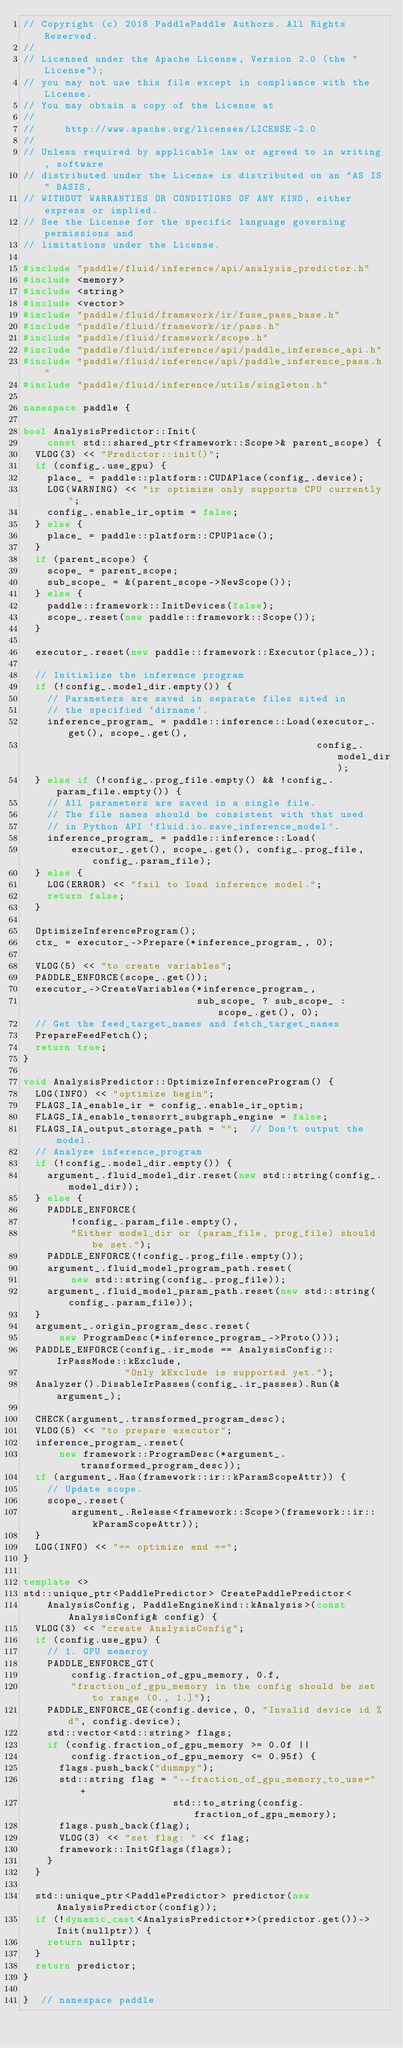<code> <loc_0><loc_0><loc_500><loc_500><_C++_>// Copyright (c) 2018 PaddlePaddle Authors. All Rights Reserved.
//
// Licensed under the Apache License, Version 2.0 (the "License");
// you may not use this file except in compliance with the License.
// You may obtain a copy of the License at
//
//     http://www.apache.org/licenses/LICENSE-2.0
//
// Unless required by applicable law or agreed to in writing, software
// distributed under the License is distributed on an "AS IS" BASIS,
// WITHOUT WARRANTIES OR CONDITIONS OF ANY KIND, either express or implied.
// See the License for the specific language governing permissions and
// limitations under the License.

#include "paddle/fluid/inference/api/analysis_predictor.h"
#include <memory>
#include <string>
#include <vector>
#include "paddle/fluid/framework/ir/fuse_pass_base.h"
#include "paddle/fluid/framework/ir/pass.h"
#include "paddle/fluid/framework/scope.h"
#include "paddle/fluid/inference/api/paddle_inference_api.h"
#include "paddle/fluid/inference/api/paddle_inference_pass.h"
#include "paddle/fluid/inference/utils/singleton.h"

namespace paddle {

bool AnalysisPredictor::Init(
    const std::shared_ptr<framework::Scope>& parent_scope) {
  VLOG(3) << "Predictor::init()";
  if (config_.use_gpu) {
    place_ = paddle::platform::CUDAPlace(config_.device);
    LOG(WARNING) << "ir optimize only supports CPU currently";
    config_.enable_ir_optim = false;
  } else {
    place_ = paddle::platform::CPUPlace();
  }
  if (parent_scope) {
    scope_ = parent_scope;
    sub_scope_ = &(parent_scope->NewScope());
  } else {
    paddle::framework::InitDevices(false);
    scope_.reset(new paddle::framework::Scope());
  }

  executor_.reset(new paddle::framework::Executor(place_));

  // Initialize the inference program
  if (!config_.model_dir.empty()) {
    // Parameters are saved in separate files sited in
    // the specified `dirname`.
    inference_program_ = paddle::inference::Load(executor_.get(), scope_.get(),
                                                 config_.model_dir);
  } else if (!config_.prog_file.empty() && !config_.param_file.empty()) {
    // All parameters are saved in a single file.
    // The file names should be consistent with that used
    // in Python API `fluid.io.save_inference_model`.
    inference_program_ = paddle::inference::Load(
        executor_.get(), scope_.get(), config_.prog_file, config_.param_file);
  } else {
    LOG(ERROR) << "fail to load inference model.";
    return false;
  }

  OptimizeInferenceProgram();
  ctx_ = executor_->Prepare(*inference_program_, 0);

  VLOG(5) << "to create variables";
  PADDLE_ENFORCE(scope_.get());
  executor_->CreateVariables(*inference_program_,
                             sub_scope_ ? sub_scope_ : scope_.get(), 0);
  // Get the feed_target_names and fetch_target_names
  PrepareFeedFetch();
  return true;
}

void AnalysisPredictor::OptimizeInferenceProgram() {
  LOG(INFO) << "optimize begin";
  FLAGS_IA_enable_ir = config_.enable_ir_optim;
  FLAGS_IA_enable_tensorrt_subgraph_engine = false;
  FLAGS_IA_output_storage_path = "";  // Don't output the model.
  // Analyze inference_program
  if (!config_.model_dir.empty()) {
    argument_.fluid_model_dir.reset(new std::string(config_.model_dir));
  } else {
    PADDLE_ENFORCE(
        !config_.param_file.empty(),
        "Either model_dir or (param_file, prog_file) should be set.");
    PADDLE_ENFORCE(!config_.prog_file.empty());
    argument_.fluid_model_program_path.reset(
        new std::string(config_.prog_file));
    argument_.fluid_model_param_path.reset(new std::string(config_.param_file));
  }
  argument_.origin_program_desc.reset(
      new ProgramDesc(*inference_program_->Proto()));
  PADDLE_ENFORCE(config_.ir_mode == AnalysisConfig::IrPassMode::kExclude,
                 "Only kExclude is supported yet.");
  Analyzer().DisableIrPasses(config_.ir_passes).Run(&argument_);

  CHECK(argument_.transformed_program_desc);
  VLOG(5) << "to prepare executor";
  inference_program_.reset(
      new framework::ProgramDesc(*argument_.transformed_program_desc));
  if (argument_.Has(framework::ir::kParamScopeAttr)) {
    // Update scope.
    scope_.reset(
        argument_.Release<framework::Scope>(framework::ir::kParamScopeAttr));
  }
  LOG(INFO) << "== optimize end ==";
}

template <>
std::unique_ptr<PaddlePredictor> CreatePaddlePredictor<
    AnalysisConfig, PaddleEngineKind::kAnalysis>(const AnalysisConfig& config) {
  VLOG(3) << "create AnalysisConfig";
  if (config.use_gpu) {
    // 1. GPU memeroy
    PADDLE_ENFORCE_GT(
        config.fraction_of_gpu_memory, 0.f,
        "fraction_of_gpu_memory in the config should be set to range (0., 1.]");
    PADDLE_ENFORCE_GE(config.device, 0, "Invalid device id %d", config.device);
    std::vector<std::string> flags;
    if (config.fraction_of_gpu_memory >= 0.0f ||
        config.fraction_of_gpu_memory <= 0.95f) {
      flags.push_back("dummpy");
      std::string flag = "--fraction_of_gpu_memory_to_use=" +
                         std::to_string(config.fraction_of_gpu_memory);
      flags.push_back(flag);
      VLOG(3) << "set flag: " << flag;
      framework::InitGflags(flags);
    }
  }

  std::unique_ptr<PaddlePredictor> predictor(new AnalysisPredictor(config));
  if (!dynamic_cast<AnalysisPredictor*>(predictor.get())->Init(nullptr)) {
    return nullptr;
  }
  return predictor;
}

}  // namespace paddle
</code> 